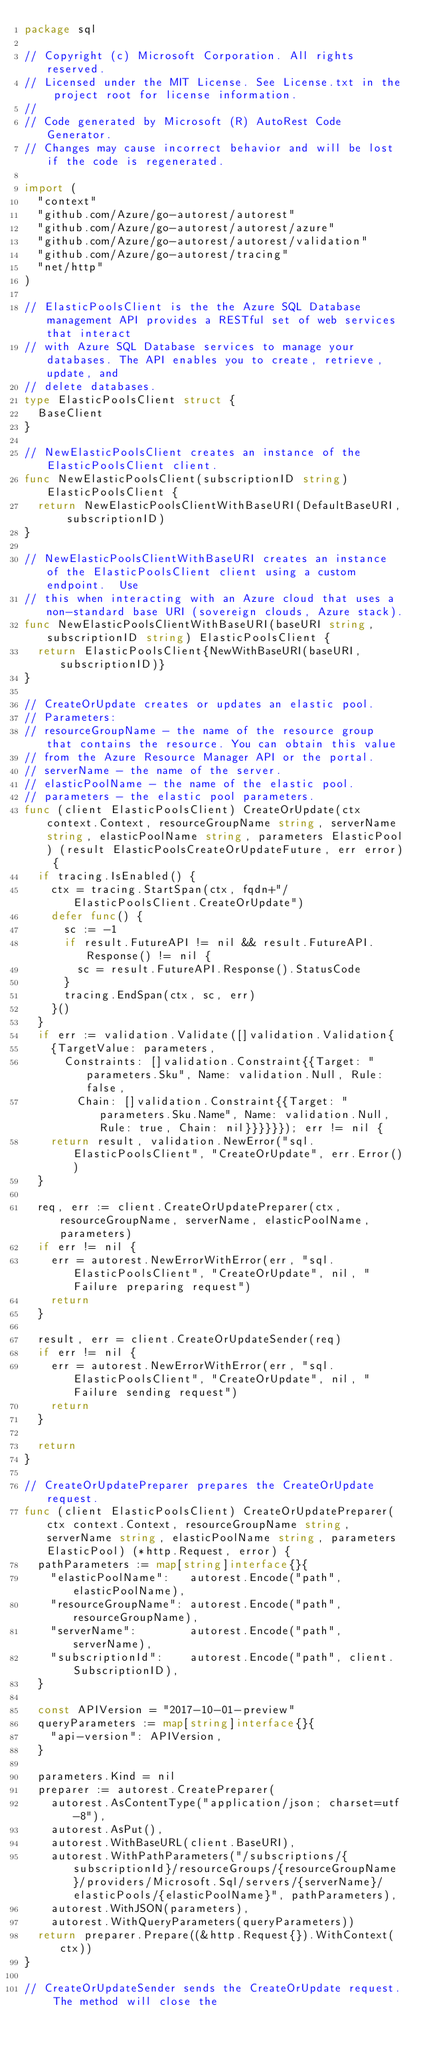Convert code to text. <code><loc_0><loc_0><loc_500><loc_500><_Go_>package sql

// Copyright (c) Microsoft Corporation. All rights reserved.
// Licensed under the MIT License. See License.txt in the project root for license information.
//
// Code generated by Microsoft (R) AutoRest Code Generator.
// Changes may cause incorrect behavior and will be lost if the code is regenerated.

import (
	"context"
	"github.com/Azure/go-autorest/autorest"
	"github.com/Azure/go-autorest/autorest/azure"
	"github.com/Azure/go-autorest/autorest/validation"
	"github.com/Azure/go-autorest/tracing"
	"net/http"
)

// ElasticPoolsClient is the the Azure SQL Database management API provides a RESTful set of web services that interact
// with Azure SQL Database services to manage your databases. The API enables you to create, retrieve, update, and
// delete databases.
type ElasticPoolsClient struct {
	BaseClient
}

// NewElasticPoolsClient creates an instance of the ElasticPoolsClient client.
func NewElasticPoolsClient(subscriptionID string) ElasticPoolsClient {
	return NewElasticPoolsClientWithBaseURI(DefaultBaseURI, subscriptionID)
}

// NewElasticPoolsClientWithBaseURI creates an instance of the ElasticPoolsClient client using a custom endpoint.  Use
// this when interacting with an Azure cloud that uses a non-standard base URI (sovereign clouds, Azure stack).
func NewElasticPoolsClientWithBaseURI(baseURI string, subscriptionID string) ElasticPoolsClient {
	return ElasticPoolsClient{NewWithBaseURI(baseURI, subscriptionID)}
}

// CreateOrUpdate creates or updates an elastic pool.
// Parameters:
// resourceGroupName - the name of the resource group that contains the resource. You can obtain this value
// from the Azure Resource Manager API or the portal.
// serverName - the name of the server.
// elasticPoolName - the name of the elastic pool.
// parameters - the elastic pool parameters.
func (client ElasticPoolsClient) CreateOrUpdate(ctx context.Context, resourceGroupName string, serverName string, elasticPoolName string, parameters ElasticPool) (result ElasticPoolsCreateOrUpdateFuture, err error) {
	if tracing.IsEnabled() {
		ctx = tracing.StartSpan(ctx, fqdn+"/ElasticPoolsClient.CreateOrUpdate")
		defer func() {
			sc := -1
			if result.FutureAPI != nil && result.FutureAPI.Response() != nil {
				sc = result.FutureAPI.Response().StatusCode
			}
			tracing.EndSpan(ctx, sc, err)
		}()
	}
	if err := validation.Validate([]validation.Validation{
		{TargetValue: parameters,
			Constraints: []validation.Constraint{{Target: "parameters.Sku", Name: validation.Null, Rule: false,
				Chain: []validation.Constraint{{Target: "parameters.Sku.Name", Name: validation.Null, Rule: true, Chain: nil}}}}}}); err != nil {
		return result, validation.NewError("sql.ElasticPoolsClient", "CreateOrUpdate", err.Error())
	}

	req, err := client.CreateOrUpdatePreparer(ctx, resourceGroupName, serverName, elasticPoolName, parameters)
	if err != nil {
		err = autorest.NewErrorWithError(err, "sql.ElasticPoolsClient", "CreateOrUpdate", nil, "Failure preparing request")
		return
	}

	result, err = client.CreateOrUpdateSender(req)
	if err != nil {
		err = autorest.NewErrorWithError(err, "sql.ElasticPoolsClient", "CreateOrUpdate", nil, "Failure sending request")
		return
	}

	return
}

// CreateOrUpdatePreparer prepares the CreateOrUpdate request.
func (client ElasticPoolsClient) CreateOrUpdatePreparer(ctx context.Context, resourceGroupName string, serverName string, elasticPoolName string, parameters ElasticPool) (*http.Request, error) {
	pathParameters := map[string]interface{}{
		"elasticPoolName":   autorest.Encode("path", elasticPoolName),
		"resourceGroupName": autorest.Encode("path", resourceGroupName),
		"serverName":        autorest.Encode("path", serverName),
		"subscriptionId":    autorest.Encode("path", client.SubscriptionID),
	}

	const APIVersion = "2017-10-01-preview"
	queryParameters := map[string]interface{}{
		"api-version": APIVersion,
	}

	parameters.Kind = nil
	preparer := autorest.CreatePreparer(
		autorest.AsContentType("application/json; charset=utf-8"),
		autorest.AsPut(),
		autorest.WithBaseURL(client.BaseURI),
		autorest.WithPathParameters("/subscriptions/{subscriptionId}/resourceGroups/{resourceGroupName}/providers/Microsoft.Sql/servers/{serverName}/elasticPools/{elasticPoolName}", pathParameters),
		autorest.WithJSON(parameters),
		autorest.WithQueryParameters(queryParameters))
	return preparer.Prepare((&http.Request{}).WithContext(ctx))
}

// CreateOrUpdateSender sends the CreateOrUpdate request. The method will close the</code> 